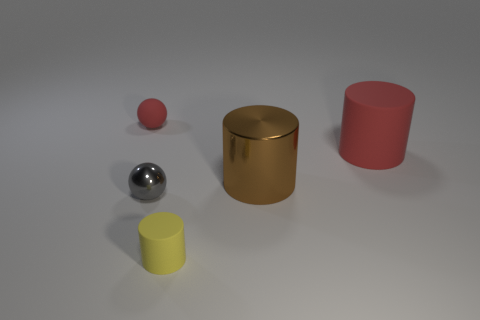Add 4 rubber cylinders. How many objects exist? 9 Subtract all red spheres. How many spheres are left? 1 Subtract all metallic cylinders. How many cylinders are left? 2 Subtract 0 cyan cylinders. How many objects are left? 5 Subtract all cylinders. How many objects are left? 2 Subtract 1 spheres. How many spheres are left? 1 Subtract all blue cylinders. Subtract all yellow balls. How many cylinders are left? 3 Subtract all yellow cylinders. How many green spheres are left? 0 Subtract all tiny matte cylinders. Subtract all red objects. How many objects are left? 2 Add 2 big brown cylinders. How many big brown cylinders are left? 3 